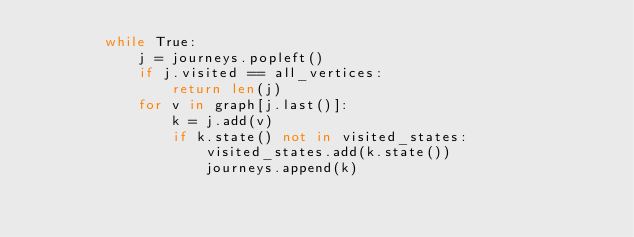Convert code to text. <code><loc_0><loc_0><loc_500><loc_500><_Python_>        while True:
            j = journeys.popleft()
            if j.visited == all_vertices:
                return len(j)
            for v in graph[j.last()]:
                k = j.add(v)
                if k.state() not in visited_states:
                    visited_states.add(k.state())
                    journeys.append(k)
</code> 